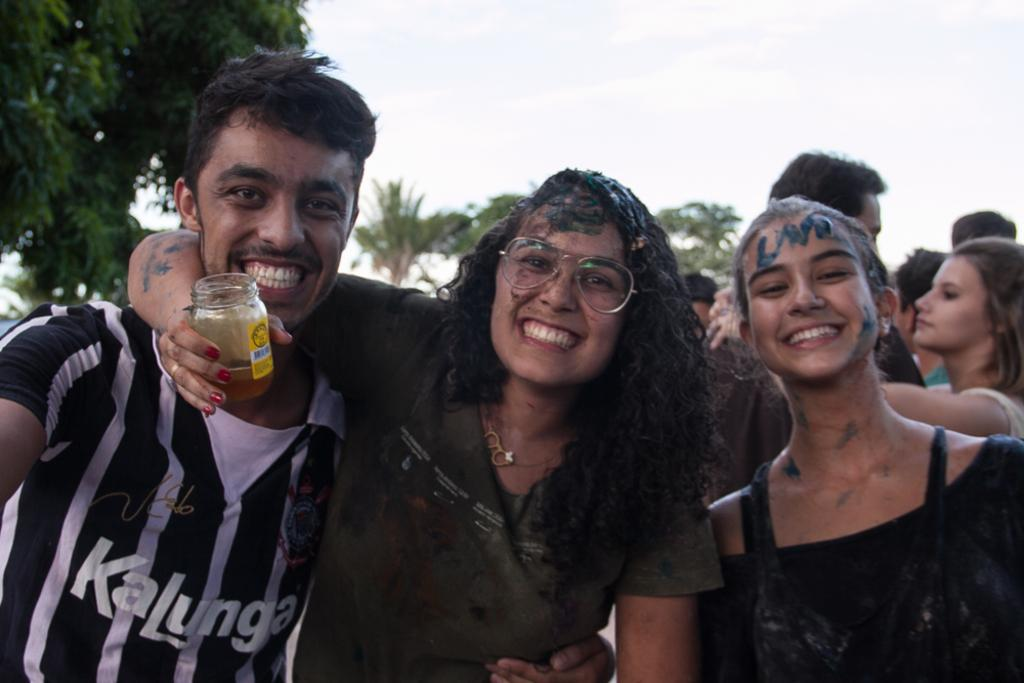How many people are in the image? There are many people in the image. What else can be seen besides people in the image? There are many trees in the image. Can you describe the people in the front of the image? There are three persons in the front of the image. What is the woman in the middle of the image holding? The woman in the middle of the image holds a glass bottle. What accessory does the woman in the middle of the image wear? The woman in the middle of the image wears spectacles. What is visible at the top of the image? The sky is visible at the top of the image. What type of writing can be seen on the glass bottle held by the woman in the image? There is no writing visible on the glass bottle held by the woman in the image. How does the earthquake affect the people and trees in the image? There is no mention of an earthquake in the image, so its effects cannot be determined. 